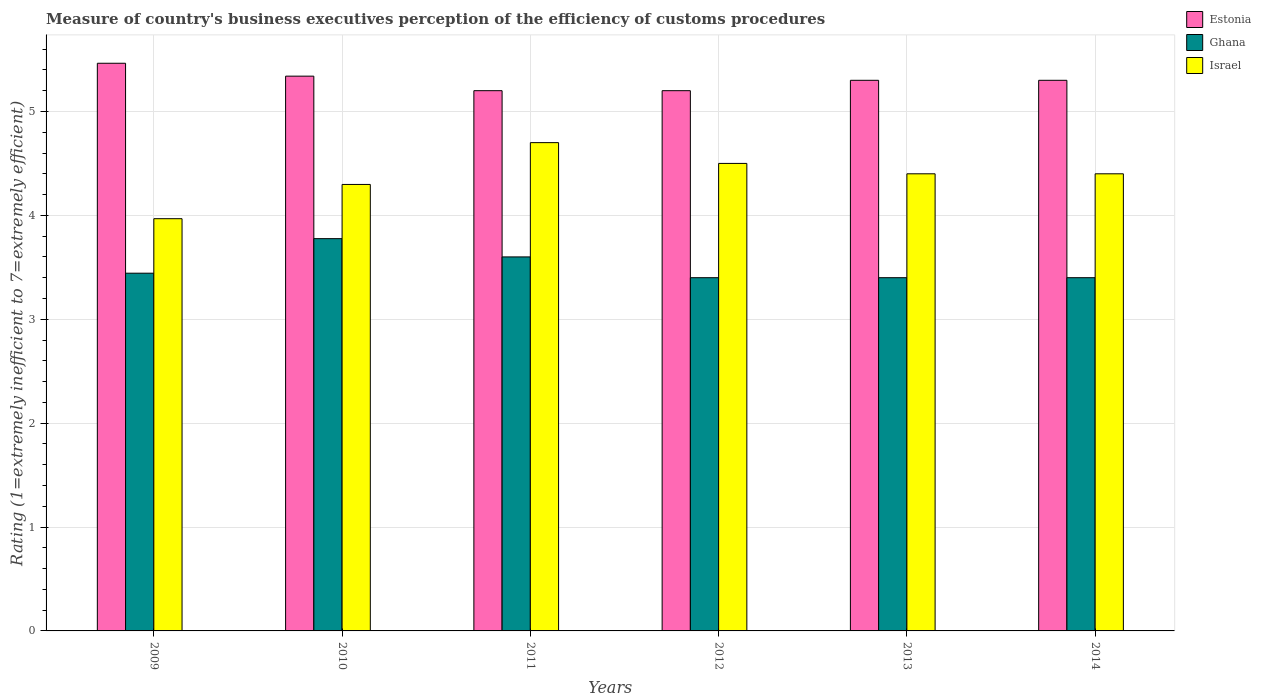How many groups of bars are there?
Provide a short and direct response. 6. Are the number of bars on each tick of the X-axis equal?
Offer a terse response. Yes. How many bars are there on the 3rd tick from the right?
Keep it short and to the point. 3. What is the rating of the efficiency of customs procedure in Ghana in 2013?
Provide a short and direct response. 3.4. Across all years, what is the minimum rating of the efficiency of customs procedure in Israel?
Offer a very short reply. 3.97. What is the total rating of the efficiency of customs procedure in Estonia in the graph?
Offer a very short reply. 31.8. What is the difference between the rating of the efficiency of customs procedure in Estonia in 2011 and that in 2014?
Provide a succinct answer. -0.1. What is the difference between the rating of the efficiency of customs procedure in Israel in 2014 and the rating of the efficiency of customs procedure in Ghana in 2012?
Keep it short and to the point. 1. What is the average rating of the efficiency of customs procedure in Ghana per year?
Offer a very short reply. 3.5. In the year 2009, what is the difference between the rating of the efficiency of customs procedure in Israel and rating of the efficiency of customs procedure in Ghana?
Provide a short and direct response. 0.52. What is the ratio of the rating of the efficiency of customs procedure in Israel in 2011 to that in 2012?
Provide a short and direct response. 1.04. Is the difference between the rating of the efficiency of customs procedure in Israel in 2010 and 2013 greater than the difference between the rating of the efficiency of customs procedure in Ghana in 2010 and 2013?
Make the answer very short. No. What is the difference between the highest and the second highest rating of the efficiency of customs procedure in Ghana?
Ensure brevity in your answer.  0.18. What is the difference between the highest and the lowest rating of the efficiency of customs procedure in Israel?
Your answer should be compact. 0.73. Is the sum of the rating of the efficiency of customs procedure in Ghana in 2009 and 2011 greater than the maximum rating of the efficiency of customs procedure in Estonia across all years?
Your response must be concise. Yes. What does the 3rd bar from the right in 2009 represents?
Offer a terse response. Estonia. Is it the case that in every year, the sum of the rating of the efficiency of customs procedure in Ghana and rating of the efficiency of customs procedure in Estonia is greater than the rating of the efficiency of customs procedure in Israel?
Your answer should be very brief. Yes. Are all the bars in the graph horizontal?
Your answer should be very brief. No. What is the difference between two consecutive major ticks on the Y-axis?
Give a very brief answer. 1. Are the values on the major ticks of Y-axis written in scientific E-notation?
Provide a short and direct response. No. Does the graph contain grids?
Ensure brevity in your answer.  Yes. How many legend labels are there?
Your answer should be very brief. 3. What is the title of the graph?
Give a very brief answer. Measure of country's business executives perception of the efficiency of customs procedures. Does "Chad" appear as one of the legend labels in the graph?
Offer a very short reply. No. What is the label or title of the X-axis?
Ensure brevity in your answer.  Years. What is the label or title of the Y-axis?
Provide a short and direct response. Rating (1=extremely inefficient to 7=extremely efficient). What is the Rating (1=extremely inefficient to 7=extremely efficient) of Estonia in 2009?
Keep it short and to the point. 5.46. What is the Rating (1=extremely inefficient to 7=extremely efficient) of Ghana in 2009?
Offer a very short reply. 3.44. What is the Rating (1=extremely inefficient to 7=extremely efficient) in Israel in 2009?
Make the answer very short. 3.97. What is the Rating (1=extremely inefficient to 7=extremely efficient) in Estonia in 2010?
Your response must be concise. 5.34. What is the Rating (1=extremely inefficient to 7=extremely efficient) in Ghana in 2010?
Make the answer very short. 3.78. What is the Rating (1=extremely inefficient to 7=extremely efficient) of Israel in 2010?
Provide a succinct answer. 4.3. What is the Rating (1=extremely inefficient to 7=extremely efficient) in Estonia in 2011?
Make the answer very short. 5.2. What is the Rating (1=extremely inefficient to 7=extremely efficient) of Estonia in 2012?
Your answer should be very brief. 5.2. What is the Rating (1=extremely inefficient to 7=extremely efficient) of Ghana in 2012?
Your response must be concise. 3.4. What is the Rating (1=extremely inefficient to 7=extremely efficient) of Israel in 2012?
Your answer should be very brief. 4.5. What is the Rating (1=extremely inefficient to 7=extremely efficient) of Estonia in 2013?
Your answer should be compact. 5.3. What is the Rating (1=extremely inefficient to 7=extremely efficient) in Israel in 2013?
Your answer should be very brief. 4.4. What is the Rating (1=extremely inefficient to 7=extremely efficient) in Ghana in 2014?
Give a very brief answer. 3.4. What is the Rating (1=extremely inefficient to 7=extremely efficient) of Israel in 2014?
Provide a short and direct response. 4.4. Across all years, what is the maximum Rating (1=extremely inefficient to 7=extremely efficient) in Estonia?
Make the answer very short. 5.46. Across all years, what is the maximum Rating (1=extremely inefficient to 7=extremely efficient) in Ghana?
Ensure brevity in your answer.  3.78. Across all years, what is the minimum Rating (1=extremely inefficient to 7=extremely efficient) in Estonia?
Provide a succinct answer. 5.2. Across all years, what is the minimum Rating (1=extremely inefficient to 7=extremely efficient) in Ghana?
Offer a very short reply. 3.4. Across all years, what is the minimum Rating (1=extremely inefficient to 7=extremely efficient) in Israel?
Give a very brief answer. 3.97. What is the total Rating (1=extremely inefficient to 7=extremely efficient) of Estonia in the graph?
Ensure brevity in your answer.  31.8. What is the total Rating (1=extremely inefficient to 7=extremely efficient) in Ghana in the graph?
Your response must be concise. 21.02. What is the total Rating (1=extremely inefficient to 7=extremely efficient) of Israel in the graph?
Provide a succinct answer. 26.27. What is the difference between the Rating (1=extremely inefficient to 7=extremely efficient) of Estonia in 2009 and that in 2010?
Provide a succinct answer. 0.12. What is the difference between the Rating (1=extremely inefficient to 7=extremely efficient) in Ghana in 2009 and that in 2010?
Provide a short and direct response. -0.33. What is the difference between the Rating (1=extremely inefficient to 7=extremely efficient) in Israel in 2009 and that in 2010?
Give a very brief answer. -0.33. What is the difference between the Rating (1=extremely inefficient to 7=extremely efficient) of Estonia in 2009 and that in 2011?
Offer a very short reply. 0.26. What is the difference between the Rating (1=extremely inefficient to 7=extremely efficient) in Ghana in 2009 and that in 2011?
Provide a succinct answer. -0.16. What is the difference between the Rating (1=extremely inefficient to 7=extremely efficient) of Israel in 2009 and that in 2011?
Provide a succinct answer. -0.73. What is the difference between the Rating (1=extremely inefficient to 7=extremely efficient) in Estonia in 2009 and that in 2012?
Make the answer very short. 0.26. What is the difference between the Rating (1=extremely inefficient to 7=extremely efficient) of Ghana in 2009 and that in 2012?
Give a very brief answer. 0.04. What is the difference between the Rating (1=extremely inefficient to 7=extremely efficient) in Israel in 2009 and that in 2012?
Offer a very short reply. -0.53. What is the difference between the Rating (1=extremely inefficient to 7=extremely efficient) in Estonia in 2009 and that in 2013?
Give a very brief answer. 0.16. What is the difference between the Rating (1=extremely inefficient to 7=extremely efficient) of Ghana in 2009 and that in 2013?
Offer a very short reply. 0.04. What is the difference between the Rating (1=extremely inefficient to 7=extremely efficient) in Israel in 2009 and that in 2013?
Offer a terse response. -0.43. What is the difference between the Rating (1=extremely inefficient to 7=extremely efficient) in Estonia in 2009 and that in 2014?
Give a very brief answer. 0.16. What is the difference between the Rating (1=extremely inefficient to 7=extremely efficient) of Ghana in 2009 and that in 2014?
Your response must be concise. 0.04. What is the difference between the Rating (1=extremely inefficient to 7=extremely efficient) of Israel in 2009 and that in 2014?
Offer a very short reply. -0.43. What is the difference between the Rating (1=extremely inefficient to 7=extremely efficient) of Estonia in 2010 and that in 2011?
Your response must be concise. 0.14. What is the difference between the Rating (1=extremely inefficient to 7=extremely efficient) in Ghana in 2010 and that in 2011?
Keep it short and to the point. 0.18. What is the difference between the Rating (1=extremely inefficient to 7=extremely efficient) of Israel in 2010 and that in 2011?
Provide a succinct answer. -0.4. What is the difference between the Rating (1=extremely inefficient to 7=extremely efficient) of Estonia in 2010 and that in 2012?
Your response must be concise. 0.14. What is the difference between the Rating (1=extremely inefficient to 7=extremely efficient) in Ghana in 2010 and that in 2012?
Your response must be concise. 0.38. What is the difference between the Rating (1=extremely inefficient to 7=extremely efficient) in Israel in 2010 and that in 2012?
Ensure brevity in your answer.  -0.2. What is the difference between the Rating (1=extremely inefficient to 7=extremely efficient) of Estonia in 2010 and that in 2013?
Your answer should be compact. 0.04. What is the difference between the Rating (1=extremely inefficient to 7=extremely efficient) in Ghana in 2010 and that in 2013?
Give a very brief answer. 0.38. What is the difference between the Rating (1=extremely inefficient to 7=extremely efficient) in Israel in 2010 and that in 2013?
Provide a succinct answer. -0.1. What is the difference between the Rating (1=extremely inefficient to 7=extremely efficient) in Estonia in 2010 and that in 2014?
Give a very brief answer. 0.04. What is the difference between the Rating (1=extremely inefficient to 7=extremely efficient) in Ghana in 2010 and that in 2014?
Provide a short and direct response. 0.38. What is the difference between the Rating (1=extremely inefficient to 7=extremely efficient) in Israel in 2010 and that in 2014?
Your answer should be very brief. -0.1. What is the difference between the Rating (1=extremely inefficient to 7=extremely efficient) of Estonia in 2011 and that in 2012?
Provide a short and direct response. 0. What is the difference between the Rating (1=extremely inefficient to 7=extremely efficient) in Ghana in 2011 and that in 2013?
Provide a short and direct response. 0.2. What is the difference between the Rating (1=extremely inefficient to 7=extremely efficient) in Israel in 2011 and that in 2013?
Provide a succinct answer. 0.3. What is the difference between the Rating (1=extremely inefficient to 7=extremely efficient) of Estonia in 2011 and that in 2014?
Ensure brevity in your answer.  -0.1. What is the difference between the Rating (1=extremely inefficient to 7=extremely efficient) in Estonia in 2012 and that in 2013?
Offer a terse response. -0.1. What is the difference between the Rating (1=extremely inefficient to 7=extremely efficient) in Estonia in 2012 and that in 2014?
Provide a short and direct response. -0.1. What is the difference between the Rating (1=extremely inefficient to 7=extremely efficient) in Ghana in 2012 and that in 2014?
Your response must be concise. 0. What is the difference between the Rating (1=extremely inefficient to 7=extremely efficient) of Estonia in 2013 and that in 2014?
Provide a succinct answer. 0. What is the difference between the Rating (1=extremely inefficient to 7=extremely efficient) in Ghana in 2013 and that in 2014?
Make the answer very short. 0. What is the difference between the Rating (1=extremely inefficient to 7=extremely efficient) in Israel in 2013 and that in 2014?
Give a very brief answer. 0. What is the difference between the Rating (1=extremely inefficient to 7=extremely efficient) of Estonia in 2009 and the Rating (1=extremely inefficient to 7=extremely efficient) of Ghana in 2010?
Provide a short and direct response. 1.69. What is the difference between the Rating (1=extremely inefficient to 7=extremely efficient) of Estonia in 2009 and the Rating (1=extremely inefficient to 7=extremely efficient) of Israel in 2010?
Ensure brevity in your answer.  1.17. What is the difference between the Rating (1=extremely inefficient to 7=extremely efficient) in Ghana in 2009 and the Rating (1=extremely inefficient to 7=extremely efficient) in Israel in 2010?
Ensure brevity in your answer.  -0.85. What is the difference between the Rating (1=extremely inefficient to 7=extremely efficient) of Estonia in 2009 and the Rating (1=extremely inefficient to 7=extremely efficient) of Ghana in 2011?
Make the answer very short. 1.86. What is the difference between the Rating (1=extremely inefficient to 7=extremely efficient) of Estonia in 2009 and the Rating (1=extremely inefficient to 7=extremely efficient) of Israel in 2011?
Keep it short and to the point. 0.76. What is the difference between the Rating (1=extremely inefficient to 7=extremely efficient) of Ghana in 2009 and the Rating (1=extremely inefficient to 7=extremely efficient) of Israel in 2011?
Your answer should be very brief. -1.26. What is the difference between the Rating (1=extremely inefficient to 7=extremely efficient) in Estonia in 2009 and the Rating (1=extremely inefficient to 7=extremely efficient) in Ghana in 2012?
Provide a short and direct response. 2.06. What is the difference between the Rating (1=extremely inefficient to 7=extremely efficient) in Estonia in 2009 and the Rating (1=extremely inefficient to 7=extremely efficient) in Israel in 2012?
Your answer should be compact. 0.96. What is the difference between the Rating (1=extremely inefficient to 7=extremely efficient) of Ghana in 2009 and the Rating (1=extremely inefficient to 7=extremely efficient) of Israel in 2012?
Provide a succinct answer. -1.06. What is the difference between the Rating (1=extremely inefficient to 7=extremely efficient) of Estonia in 2009 and the Rating (1=extremely inefficient to 7=extremely efficient) of Ghana in 2013?
Give a very brief answer. 2.06. What is the difference between the Rating (1=extremely inefficient to 7=extremely efficient) in Estonia in 2009 and the Rating (1=extremely inefficient to 7=extremely efficient) in Israel in 2013?
Your answer should be compact. 1.06. What is the difference between the Rating (1=extremely inefficient to 7=extremely efficient) in Ghana in 2009 and the Rating (1=extremely inefficient to 7=extremely efficient) in Israel in 2013?
Your response must be concise. -0.96. What is the difference between the Rating (1=extremely inefficient to 7=extremely efficient) in Estonia in 2009 and the Rating (1=extremely inefficient to 7=extremely efficient) in Ghana in 2014?
Give a very brief answer. 2.06. What is the difference between the Rating (1=extremely inefficient to 7=extremely efficient) of Estonia in 2009 and the Rating (1=extremely inefficient to 7=extremely efficient) of Israel in 2014?
Keep it short and to the point. 1.06. What is the difference between the Rating (1=extremely inefficient to 7=extremely efficient) of Ghana in 2009 and the Rating (1=extremely inefficient to 7=extremely efficient) of Israel in 2014?
Your answer should be very brief. -0.96. What is the difference between the Rating (1=extremely inefficient to 7=extremely efficient) of Estonia in 2010 and the Rating (1=extremely inefficient to 7=extremely efficient) of Ghana in 2011?
Your answer should be very brief. 1.74. What is the difference between the Rating (1=extremely inefficient to 7=extremely efficient) of Estonia in 2010 and the Rating (1=extremely inefficient to 7=extremely efficient) of Israel in 2011?
Your response must be concise. 0.64. What is the difference between the Rating (1=extremely inefficient to 7=extremely efficient) in Ghana in 2010 and the Rating (1=extremely inefficient to 7=extremely efficient) in Israel in 2011?
Your response must be concise. -0.92. What is the difference between the Rating (1=extremely inefficient to 7=extremely efficient) of Estonia in 2010 and the Rating (1=extremely inefficient to 7=extremely efficient) of Ghana in 2012?
Your answer should be very brief. 1.94. What is the difference between the Rating (1=extremely inefficient to 7=extremely efficient) in Estonia in 2010 and the Rating (1=extremely inefficient to 7=extremely efficient) in Israel in 2012?
Offer a terse response. 0.84. What is the difference between the Rating (1=extremely inefficient to 7=extremely efficient) of Ghana in 2010 and the Rating (1=extremely inefficient to 7=extremely efficient) of Israel in 2012?
Make the answer very short. -0.72. What is the difference between the Rating (1=extremely inefficient to 7=extremely efficient) in Estonia in 2010 and the Rating (1=extremely inefficient to 7=extremely efficient) in Ghana in 2013?
Offer a very short reply. 1.94. What is the difference between the Rating (1=extremely inefficient to 7=extremely efficient) in Ghana in 2010 and the Rating (1=extremely inefficient to 7=extremely efficient) in Israel in 2013?
Keep it short and to the point. -0.62. What is the difference between the Rating (1=extremely inefficient to 7=extremely efficient) of Estonia in 2010 and the Rating (1=extremely inefficient to 7=extremely efficient) of Ghana in 2014?
Provide a succinct answer. 1.94. What is the difference between the Rating (1=extremely inefficient to 7=extremely efficient) of Ghana in 2010 and the Rating (1=extremely inefficient to 7=extremely efficient) of Israel in 2014?
Make the answer very short. -0.62. What is the difference between the Rating (1=extremely inefficient to 7=extremely efficient) of Estonia in 2011 and the Rating (1=extremely inefficient to 7=extremely efficient) of Israel in 2012?
Your answer should be very brief. 0.7. What is the difference between the Rating (1=extremely inefficient to 7=extremely efficient) in Estonia in 2011 and the Rating (1=extremely inefficient to 7=extremely efficient) in Ghana in 2013?
Give a very brief answer. 1.8. What is the difference between the Rating (1=extremely inefficient to 7=extremely efficient) of Estonia in 2011 and the Rating (1=extremely inefficient to 7=extremely efficient) of Israel in 2013?
Provide a succinct answer. 0.8. What is the difference between the Rating (1=extremely inefficient to 7=extremely efficient) in Ghana in 2011 and the Rating (1=extremely inefficient to 7=extremely efficient) in Israel in 2013?
Keep it short and to the point. -0.8. What is the difference between the Rating (1=extremely inefficient to 7=extremely efficient) of Estonia in 2011 and the Rating (1=extremely inefficient to 7=extremely efficient) of Ghana in 2014?
Give a very brief answer. 1.8. What is the difference between the Rating (1=extremely inefficient to 7=extremely efficient) in Estonia in 2011 and the Rating (1=extremely inefficient to 7=extremely efficient) in Israel in 2014?
Offer a very short reply. 0.8. What is the difference between the Rating (1=extremely inefficient to 7=extremely efficient) of Ghana in 2012 and the Rating (1=extremely inefficient to 7=extremely efficient) of Israel in 2013?
Your answer should be compact. -1. What is the difference between the Rating (1=extremely inefficient to 7=extremely efficient) of Estonia in 2012 and the Rating (1=extremely inefficient to 7=extremely efficient) of Ghana in 2014?
Keep it short and to the point. 1.8. What is the difference between the Rating (1=extremely inefficient to 7=extremely efficient) in Estonia in 2012 and the Rating (1=extremely inefficient to 7=extremely efficient) in Israel in 2014?
Your response must be concise. 0.8. What is the difference between the Rating (1=extremely inefficient to 7=extremely efficient) of Estonia in 2013 and the Rating (1=extremely inefficient to 7=extremely efficient) of Ghana in 2014?
Make the answer very short. 1.9. What is the difference between the Rating (1=extremely inefficient to 7=extremely efficient) in Estonia in 2013 and the Rating (1=extremely inefficient to 7=extremely efficient) in Israel in 2014?
Offer a very short reply. 0.9. What is the average Rating (1=extremely inefficient to 7=extremely efficient) in Estonia per year?
Your response must be concise. 5.3. What is the average Rating (1=extremely inefficient to 7=extremely efficient) in Ghana per year?
Provide a succinct answer. 3.5. What is the average Rating (1=extremely inefficient to 7=extremely efficient) in Israel per year?
Provide a short and direct response. 4.38. In the year 2009, what is the difference between the Rating (1=extremely inefficient to 7=extremely efficient) of Estonia and Rating (1=extremely inefficient to 7=extremely efficient) of Ghana?
Offer a terse response. 2.02. In the year 2009, what is the difference between the Rating (1=extremely inefficient to 7=extremely efficient) in Estonia and Rating (1=extremely inefficient to 7=extremely efficient) in Israel?
Offer a very short reply. 1.5. In the year 2009, what is the difference between the Rating (1=extremely inefficient to 7=extremely efficient) of Ghana and Rating (1=extremely inefficient to 7=extremely efficient) of Israel?
Ensure brevity in your answer.  -0.52. In the year 2010, what is the difference between the Rating (1=extremely inefficient to 7=extremely efficient) in Estonia and Rating (1=extremely inefficient to 7=extremely efficient) in Ghana?
Offer a terse response. 1.56. In the year 2010, what is the difference between the Rating (1=extremely inefficient to 7=extremely efficient) of Estonia and Rating (1=extremely inefficient to 7=extremely efficient) of Israel?
Keep it short and to the point. 1.04. In the year 2010, what is the difference between the Rating (1=extremely inefficient to 7=extremely efficient) of Ghana and Rating (1=extremely inefficient to 7=extremely efficient) of Israel?
Offer a very short reply. -0.52. In the year 2011, what is the difference between the Rating (1=extremely inefficient to 7=extremely efficient) of Estonia and Rating (1=extremely inefficient to 7=extremely efficient) of Ghana?
Offer a very short reply. 1.6. In the year 2011, what is the difference between the Rating (1=extremely inefficient to 7=extremely efficient) in Estonia and Rating (1=extremely inefficient to 7=extremely efficient) in Israel?
Your response must be concise. 0.5. In the year 2012, what is the difference between the Rating (1=extremely inefficient to 7=extremely efficient) of Estonia and Rating (1=extremely inefficient to 7=extremely efficient) of Israel?
Provide a short and direct response. 0.7. In the year 2012, what is the difference between the Rating (1=extremely inefficient to 7=extremely efficient) in Ghana and Rating (1=extremely inefficient to 7=extremely efficient) in Israel?
Your response must be concise. -1.1. In the year 2013, what is the difference between the Rating (1=extremely inefficient to 7=extremely efficient) in Estonia and Rating (1=extremely inefficient to 7=extremely efficient) in Ghana?
Offer a very short reply. 1.9. In the year 2013, what is the difference between the Rating (1=extremely inefficient to 7=extremely efficient) of Estonia and Rating (1=extremely inefficient to 7=extremely efficient) of Israel?
Provide a short and direct response. 0.9. In the year 2013, what is the difference between the Rating (1=extremely inefficient to 7=extremely efficient) in Ghana and Rating (1=extremely inefficient to 7=extremely efficient) in Israel?
Your response must be concise. -1. What is the ratio of the Rating (1=extremely inefficient to 7=extremely efficient) in Estonia in 2009 to that in 2010?
Give a very brief answer. 1.02. What is the ratio of the Rating (1=extremely inefficient to 7=extremely efficient) of Ghana in 2009 to that in 2010?
Your answer should be compact. 0.91. What is the ratio of the Rating (1=extremely inefficient to 7=extremely efficient) in Israel in 2009 to that in 2010?
Offer a very short reply. 0.92. What is the ratio of the Rating (1=extremely inefficient to 7=extremely efficient) of Estonia in 2009 to that in 2011?
Keep it short and to the point. 1.05. What is the ratio of the Rating (1=extremely inefficient to 7=extremely efficient) in Ghana in 2009 to that in 2011?
Your response must be concise. 0.96. What is the ratio of the Rating (1=extremely inefficient to 7=extremely efficient) in Israel in 2009 to that in 2011?
Your response must be concise. 0.84. What is the ratio of the Rating (1=extremely inefficient to 7=extremely efficient) in Estonia in 2009 to that in 2012?
Your response must be concise. 1.05. What is the ratio of the Rating (1=extremely inefficient to 7=extremely efficient) of Ghana in 2009 to that in 2012?
Offer a terse response. 1.01. What is the ratio of the Rating (1=extremely inefficient to 7=extremely efficient) in Israel in 2009 to that in 2012?
Give a very brief answer. 0.88. What is the ratio of the Rating (1=extremely inefficient to 7=extremely efficient) in Estonia in 2009 to that in 2013?
Provide a succinct answer. 1.03. What is the ratio of the Rating (1=extremely inefficient to 7=extremely efficient) of Ghana in 2009 to that in 2013?
Provide a succinct answer. 1.01. What is the ratio of the Rating (1=extremely inefficient to 7=extremely efficient) in Israel in 2009 to that in 2013?
Your answer should be compact. 0.9. What is the ratio of the Rating (1=extremely inefficient to 7=extremely efficient) of Estonia in 2009 to that in 2014?
Your answer should be compact. 1.03. What is the ratio of the Rating (1=extremely inefficient to 7=extremely efficient) in Ghana in 2009 to that in 2014?
Your answer should be very brief. 1.01. What is the ratio of the Rating (1=extremely inefficient to 7=extremely efficient) of Israel in 2009 to that in 2014?
Provide a short and direct response. 0.9. What is the ratio of the Rating (1=extremely inefficient to 7=extremely efficient) in Estonia in 2010 to that in 2011?
Offer a very short reply. 1.03. What is the ratio of the Rating (1=extremely inefficient to 7=extremely efficient) in Ghana in 2010 to that in 2011?
Keep it short and to the point. 1.05. What is the ratio of the Rating (1=extremely inefficient to 7=extremely efficient) in Israel in 2010 to that in 2011?
Offer a very short reply. 0.91. What is the ratio of the Rating (1=extremely inefficient to 7=extremely efficient) in Estonia in 2010 to that in 2012?
Your answer should be very brief. 1.03. What is the ratio of the Rating (1=extremely inefficient to 7=extremely efficient) of Ghana in 2010 to that in 2012?
Your response must be concise. 1.11. What is the ratio of the Rating (1=extremely inefficient to 7=extremely efficient) in Israel in 2010 to that in 2012?
Provide a succinct answer. 0.95. What is the ratio of the Rating (1=extremely inefficient to 7=extremely efficient) of Estonia in 2010 to that in 2013?
Ensure brevity in your answer.  1.01. What is the ratio of the Rating (1=extremely inefficient to 7=extremely efficient) of Ghana in 2010 to that in 2013?
Offer a very short reply. 1.11. What is the ratio of the Rating (1=extremely inefficient to 7=extremely efficient) of Israel in 2010 to that in 2013?
Provide a short and direct response. 0.98. What is the ratio of the Rating (1=extremely inefficient to 7=extremely efficient) of Estonia in 2010 to that in 2014?
Make the answer very short. 1.01. What is the ratio of the Rating (1=extremely inefficient to 7=extremely efficient) of Ghana in 2010 to that in 2014?
Ensure brevity in your answer.  1.11. What is the ratio of the Rating (1=extremely inefficient to 7=extremely efficient) in Israel in 2010 to that in 2014?
Provide a short and direct response. 0.98. What is the ratio of the Rating (1=extremely inefficient to 7=extremely efficient) in Estonia in 2011 to that in 2012?
Give a very brief answer. 1. What is the ratio of the Rating (1=extremely inefficient to 7=extremely efficient) of Ghana in 2011 to that in 2012?
Keep it short and to the point. 1.06. What is the ratio of the Rating (1=extremely inefficient to 7=extremely efficient) in Israel in 2011 to that in 2012?
Provide a succinct answer. 1.04. What is the ratio of the Rating (1=extremely inefficient to 7=extremely efficient) in Estonia in 2011 to that in 2013?
Ensure brevity in your answer.  0.98. What is the ratio of the Rating (1=extremely inefficient to 7=extremely efficient) of Ghana in 2011 to that in 2013?
Give a very brief answer. 1.06. What is the ratio of the Rating (1=extremely inefficient to 7=extremely efficient) of Israel in 2011 to that in 2013?
Provide a succinct answer. 1.07. What is the ratio of the Rating (1=extremely inefficient to 7=extremely efficient) in Estonia in 2011 to that in 2014?
Make the answer very short. 0.98. What is the ratio of the Rating (1=extremely inefficient to 7=extremely efficient) in Ghana in 2011 to that in 2014?
Ensure brevity in your answer.  1.06. What is the ratio of the Rating (1=extremely inefficient to 7=extremely efficient) in Israel in 2011 to that in 2014?
Give a very brief answer. 1.07. What is the ratio of the Rating (1=extremely inefficient to 7=extremely efficient) in Estonia in 2012 to that in 2013?
Give a very brief answer. 0.98. What is the ratio of the Rating (1=extremely inefficient to 7=extremely efficient) of Israel in 2012 to that in 2013?
Make the answer very short. 1.02. What is the ratio of the Rating (1=extremely inefficient to 7=extremely efficient) in Estonia in 2012 to that in 2014?
Your answer should be compact. 0.98. What is the ratio of the Rating (1=extremely inefficient to 7=extremely efficient) of Israel in 2012 to that in 2014?
Your response must be concise. 1.02. What is the ratio of the Rating (1=extremely inefficient to 7=extremely efficient) of Israel in 2013 to that in 2014?
Your response must be concise. 1. What is the difference between the highest and the second highest Rating (1=extremely inefficient to 7=extremely efficient) of Estonia?
Your answer should be very brief. 0.12. What is the difference between the highest and the second highest Rating (1=extremely inefficient to 7=extremely efficient) in Ghana?
Make the answer very short. 0.18. What is the difference between the highest and the lowest Rating (1=extremely inefficient to 7=extremely efficient) in Estonia?
Your answer should be compact. 0.26. What is the difference between the highest and the lowest Rating (1=extremely inefficient to 7=extremely efficient) in Ghana?
Your response must be concise. 0.38. What is the difference between the highest and the lowest Rating (1=extremely inefficient to 7=extremely efficient) of Israel?
Provide a short and direct response. 0.73. 